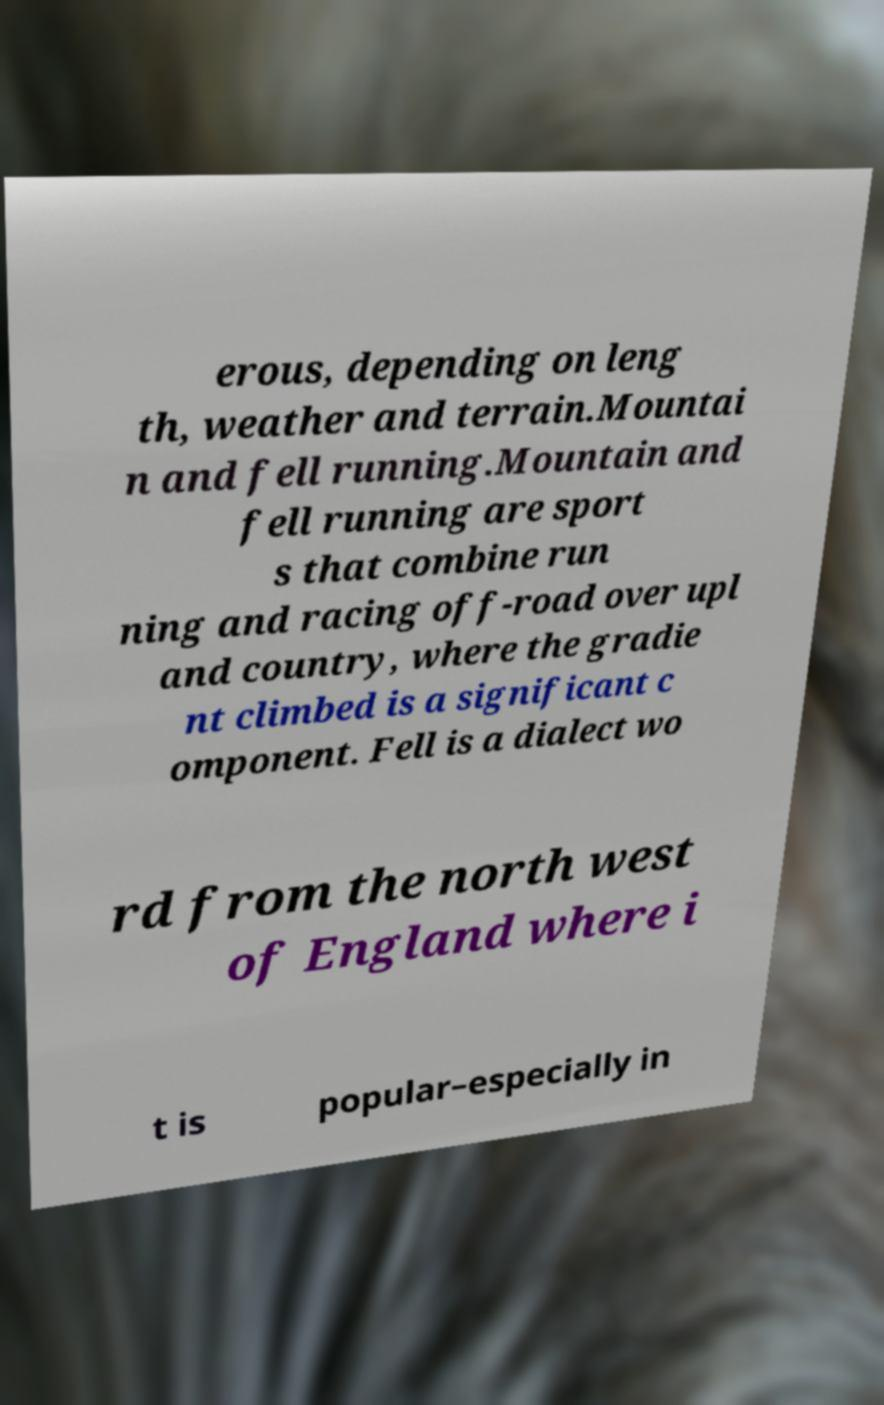I need the written content from this picture converted into text. Can you do that? erous, depending on leng th, weather and terrain.Mountai n and fell running.Mountain and fell running are sport s that combine run ning and racing off-road over upl and country, where the gradie nt climbed is a significant c omponent. Fell is a dialect wo rd from the north west of England where i t is popular–especially in 